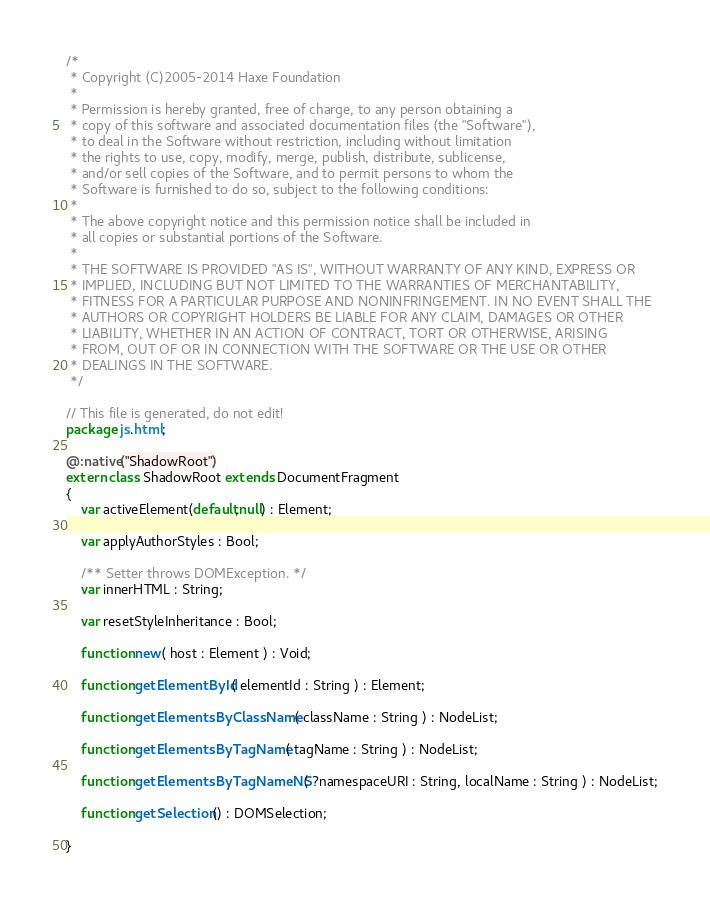<code> <loc_0><loc_0><loc_500><loc_500><_Haxe_>/*
 * Copyright (C)2005-2014 Haxe Foundation
 *
 * Permission is hereby granted, free of charge, to any person obtaining a
 * copy of this software and associated documentation files (the "Software"),
 * to deal in the Software without restriction, including without limitation
 * the rights to use, copy, modify, merge, publish, distribute, sublicense,
 * and/or sell copies of the Software, and to permit persons to whom the
 * Software is furnished to do so, subject to the following conditions:
 *
 * The above copyright notice and this permission notice shall be included in
 * all copies or substantial portions of the Software.
 *
 * THE SOFTWARE IS PROVIDED "AS IS", WITHOUT WARRANTY OF ANY KIND, EXPRESS OR
 * IMPLIED, INCLUDING BUT NOT LIMITED TO THE WARRANTIES OF MERCHANTABILITY,
 * FITNESS FOR A PARTICULAR PURPOSE AND NONINFRINGEMENT. IN NO EVENT SHALL THE
 * AUTHORS OR COPYRIGHT HOLDERS BE LIABLE FOR ANY CLAIM, DAMAGES OR OTHER
 * LIABILITY, WHETHER IN AN ACTION OF CONTRACT, TORT OR OTHERWISE, ARISING
 * FROM, OUT OF OR IN CONNECTION WITH THE SOFTWARE OR THE USE OR OTHER
 * DEALINGS IN THE SOFTWARE.
 */

// This file is generated, do not edit!
package js.html;

@:native("ShadowRoot")
extern class ShadowRoot extends DocumentFragment
{
	var activeElement(default,null) : Element;

	var applyAuthorStyles : Bool;

	/** Setter throws DOMException. */
	var innerHTML : String;

	var resetStyleInheritance : Bool;

	function new( host : Element ) : Void;

	function getElementById( elementId : String ) : Element;

	function getElementsByClassName( className : String ) : NodeList;

	function getElementsByTagName( tagName : String ) : NodeList;

	function getElementsByTagNameNS( ?namespaceURI : String, localName : String ) : NodeList;

	function getSelection() : DOMSelection;

}
</code> 